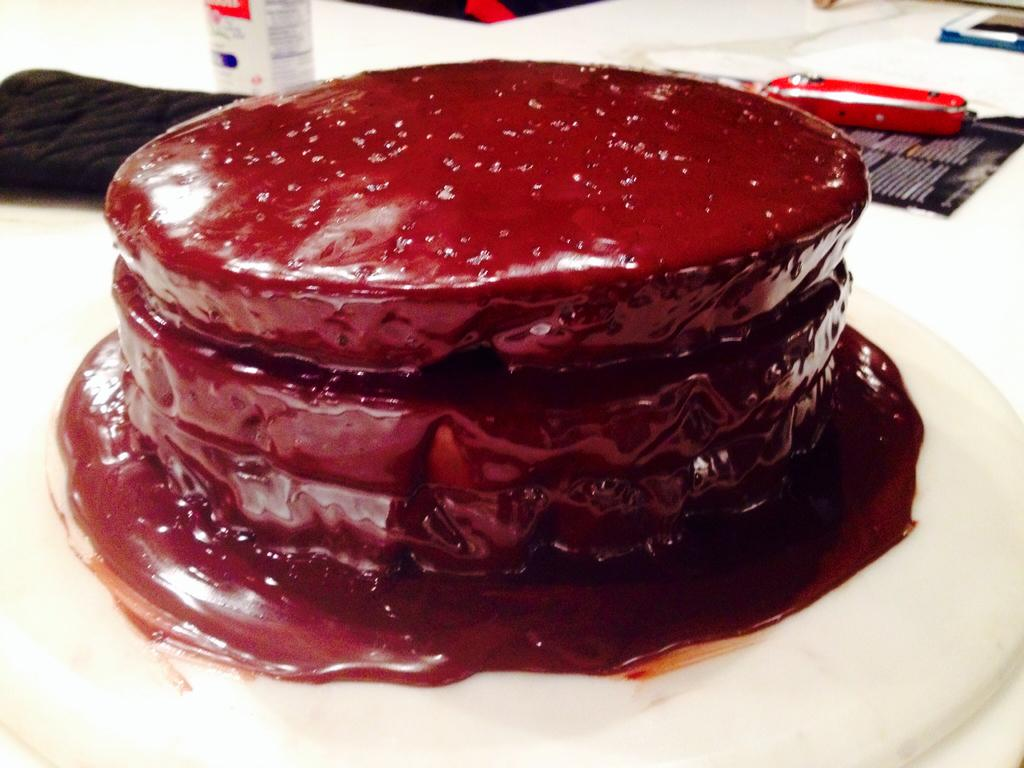What is located at the bottom of the image? There is a plate at the bottom of the image. What is on the plate? The plate contains food items. What can be seen in the background of the image? There is a knife and a paper in the background of the image. Are there any other objects visible in the background? Yes, there are other objects visible in the background of the image. What type of effect does the meal have on the mice in the image? There are no mice present in the image, so it is not possible to determine any effect on them. 